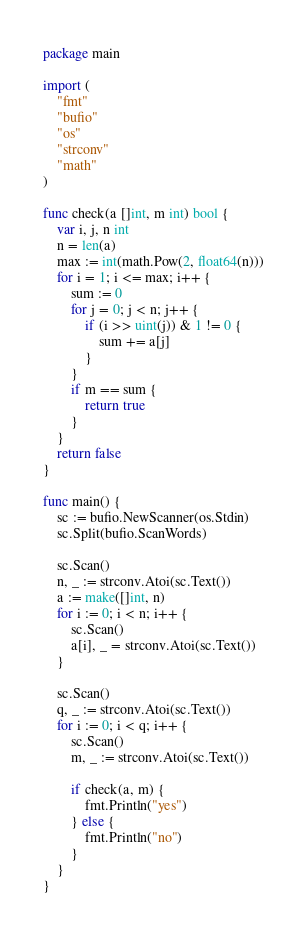<code> <loc_0><loc_0><loc_500><loc_500><_Go_>package main

import (
	"fmt"
	"bufio"
	"os"
	"strconv"
	"math"
)

func check(a []int, m int) bool {
	var i, j, n int
	n = len(a)
	max := int(math.Pow(2, float64(n)))
	for i = 1; i <= max; i++ {
		sum := 0
		for j = 0; j < n; j++ {
			if (i >> uint(j)) & 1 != 0 {
				sum += a[j]
			}
		}
		if m == sum {
			return true
		}
	}
	return false
}

func main() {
	sc := bufio.NewScanner(os.Stdin)
	sc.Split(bufio.ScanWords)

	sc.Scan()
	n, _ := strconv.Atoi(sc.Text())
	a := make([]int, n)
	for i := 0; i < n; i++ {
		sc.Scan()
		a[i], _ = strconv.Atoi(sc.Text())
	}

	sc.Scan()
	q, _ := strconv.Atoi(sc.Text())
	for i := 0; i < q; i++ {
		sc.Scan()
		m, _ := strconv.Atoi(sc.Text())

		if check(a, m) {
			fmt.Println("yes")
		} else {
			fmt.Println("no")
		}
	}
}

</code> 